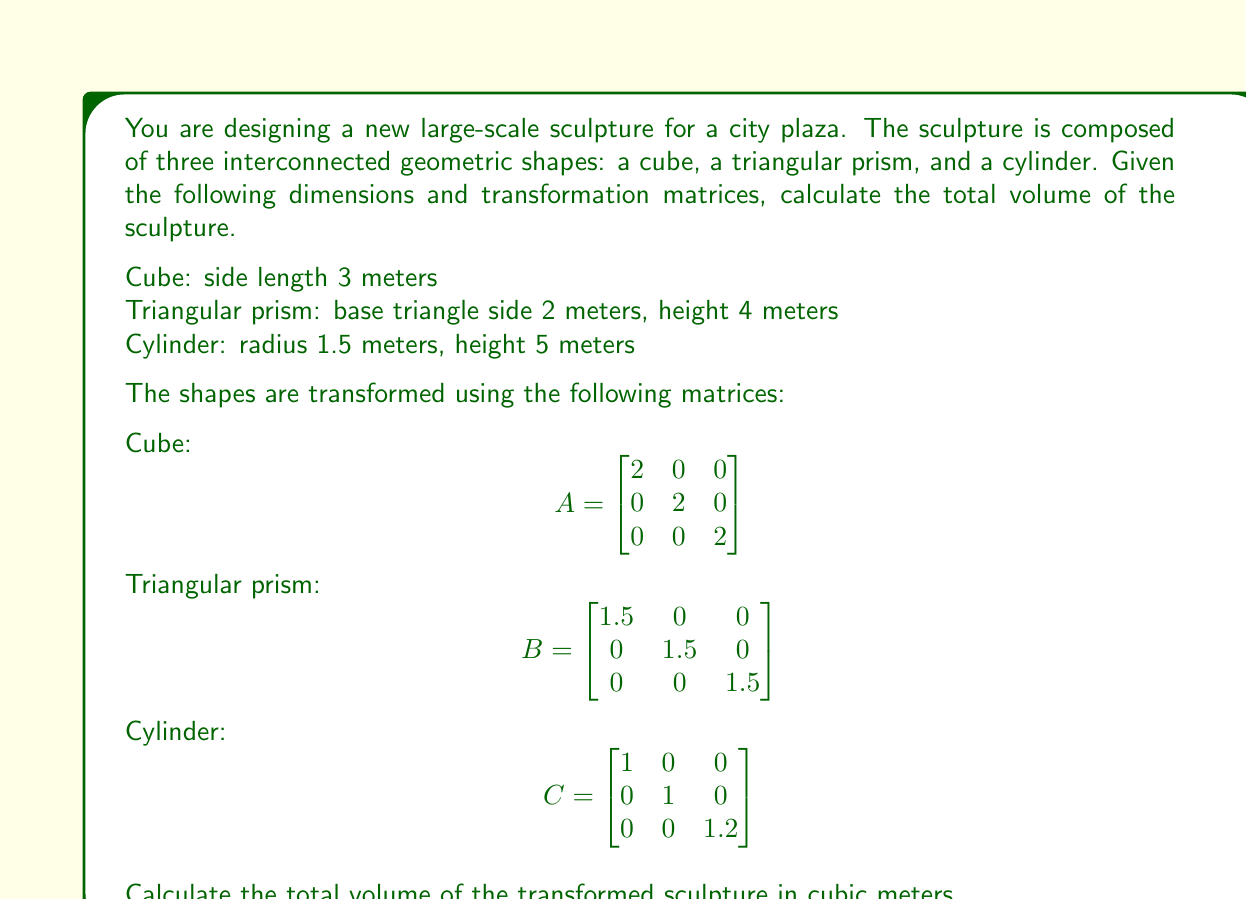Can you solve this math problem? To solve this problem, we need to calculate the volume of each shape separately, apply the transformation matrices, and then sum the results.

1. Cube:
   - Initial volume: $V_c = 3^3 = 27$ m³
   - Transformation matrix $A$ scales the cube by a factor of 2 in all dimensions
   - Determinant of $A$: $\det(A) = 2 \cdot 2 \cdot 2 = 8$
   - Transformed volume: $V_c' = 27 \cdot 8 = 216$ m³

2. Triangular prism:
   - Base area: $A = \frac{\sqrt{3}}{4} \cdot 2^2 = \sqrt{3}$ m²
   - Initial volume: $V_t = \sqrt{3} \cdot 4 = 4\sqrt{3}$ m³
   - Transformation matrix $B$ scales the prism by a factor of 1.5 in all dimensions
   - Determinant of $B$: $\det(B) = 1.5 \cdot 1.5 \cdot 1.5 = 3.375$
   - Transformed volume: $V_t' = 4\sqrt{3} \cdot 3.375 = 13.5\sqrt{3}$ m³

3. Cylinder:
   - Initial volume: $V_{cyl} = \pi r^2 h = \pi \cdot 1.5^2 \cdot 5 = 11.25\pi$ m³
   - Transformation matrix $C$ scales the cylinder by a factor of 1.2 in the height
   - Determinant of $C$: $\det(C) = 1 \cdot 1 \cdot 1.2 = 1.2$
   - Transformed volume: $V_{cyl}' = 11.25\pi \cdot 1.2 = 13.5\pi$ m³

Total volume of the transformed sculpture:
$$V_{total} = V_c' + V_t' + V_{cyl}'$$
$$V_{total} = 216 + 13.5\sqrt{3} + 13.5\pi$$
Answer: $216 + 13.5\sqrt{3} + 13.5\pi$ cubic meters 